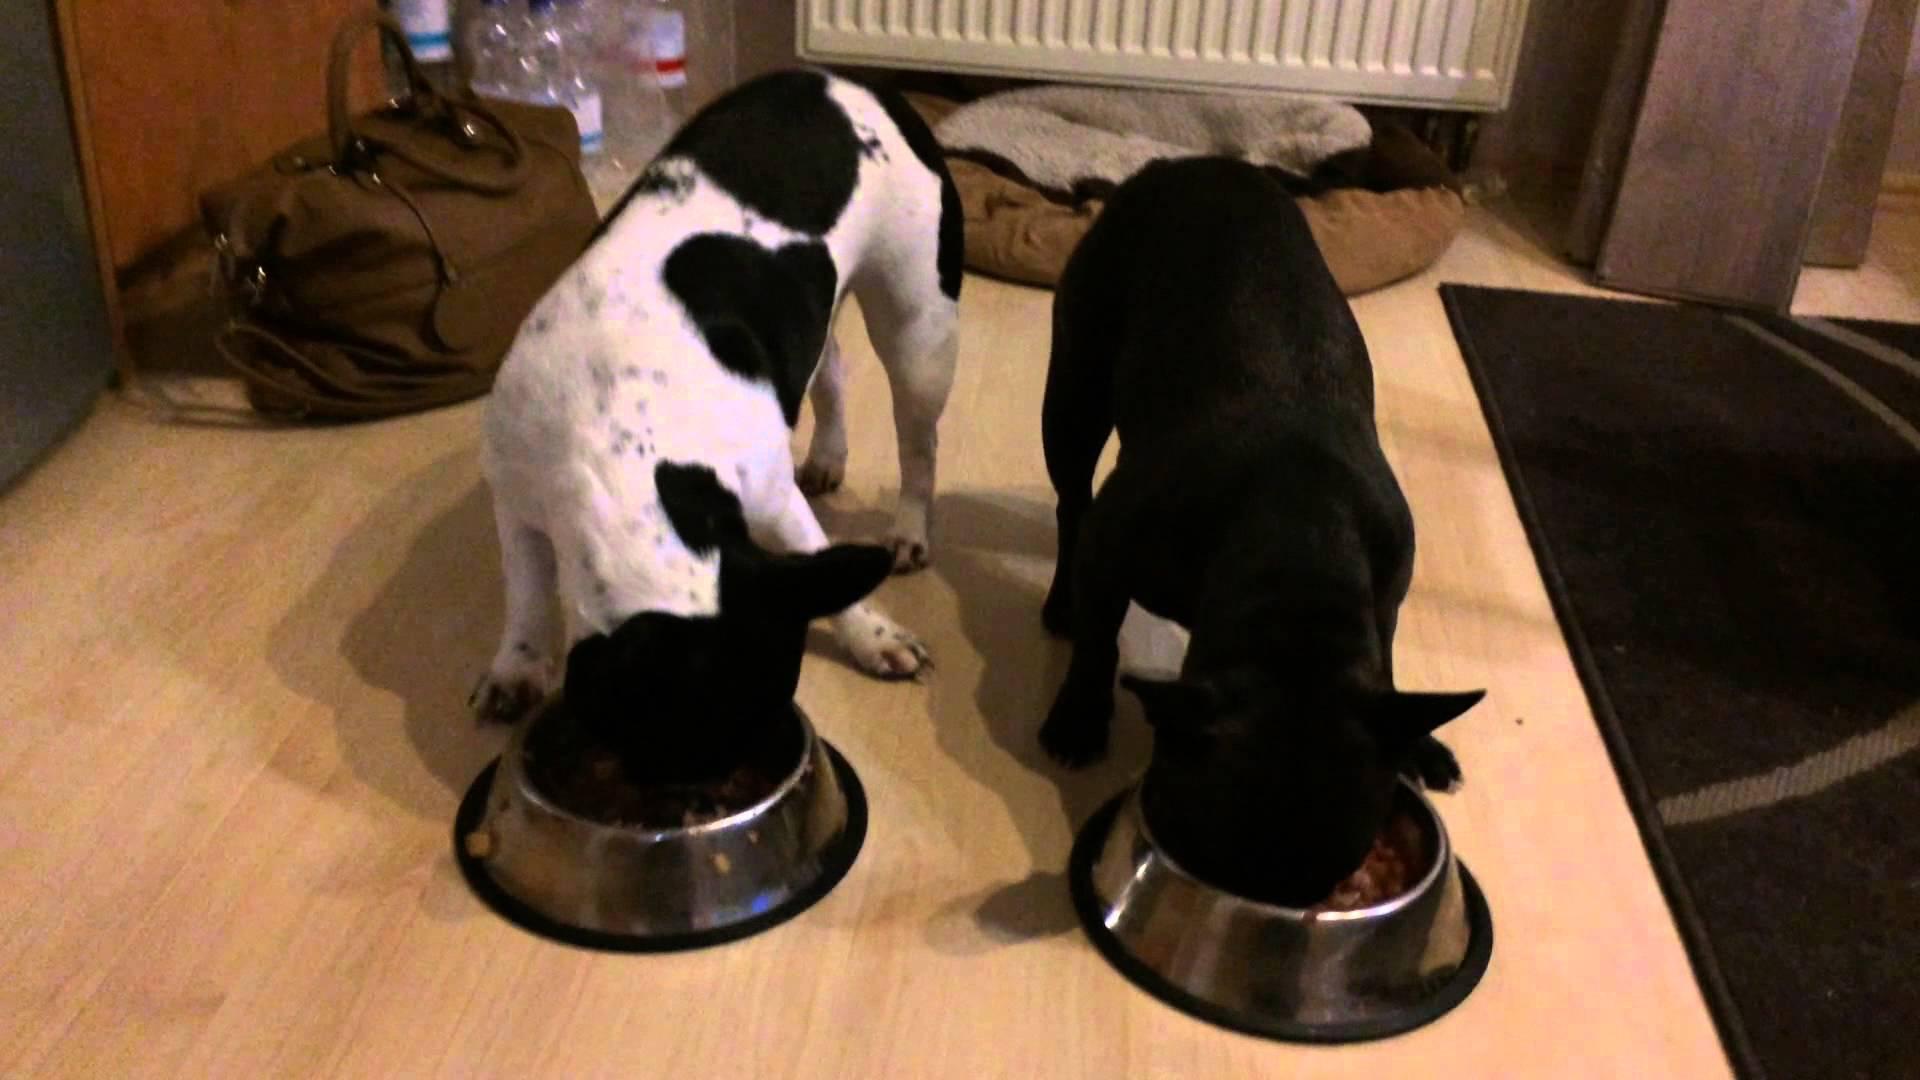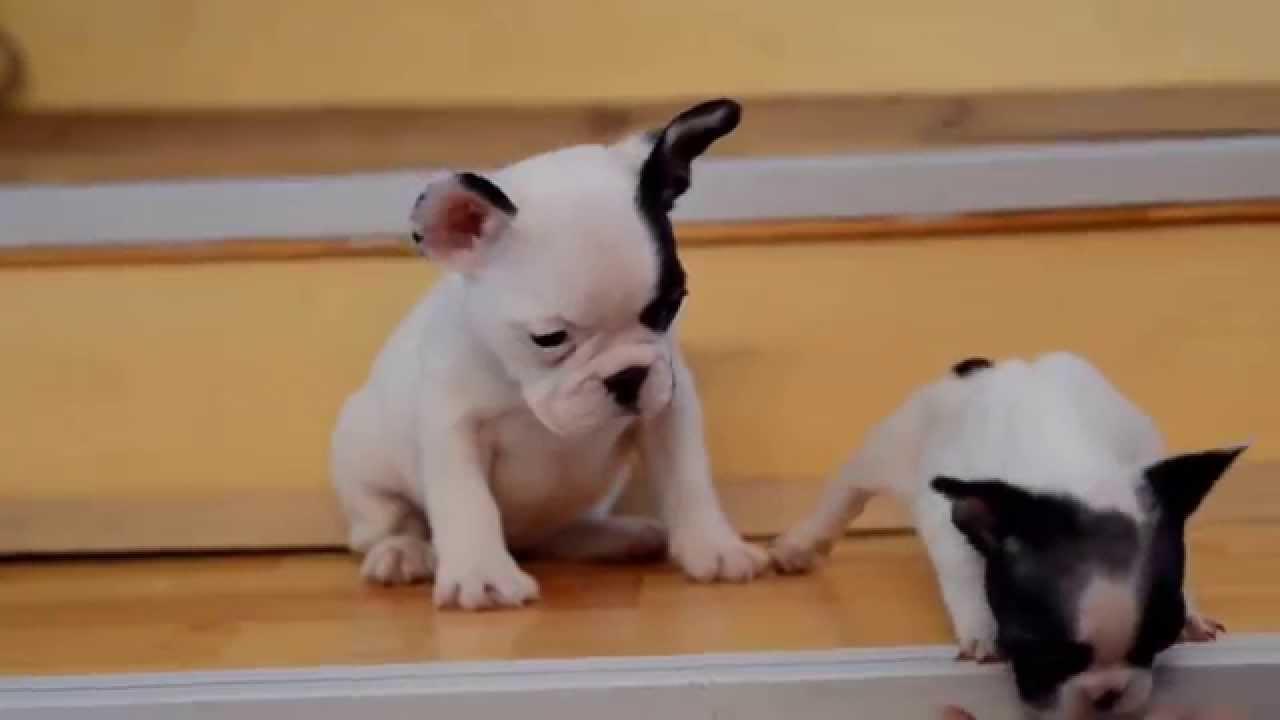The first image is the image on the left, the second image is the image on the right. Examine the images to the left and right. Is the description "A black-and-white faced dog is leaning back on its haunches and at least appears to face another animal." accurate? Answer yes or no. No. The first image is the image on the left, the second image is the image on the right. Considering the images on both sides, is "There are puppies in each image." valid? Answer yes or no. Yes. 